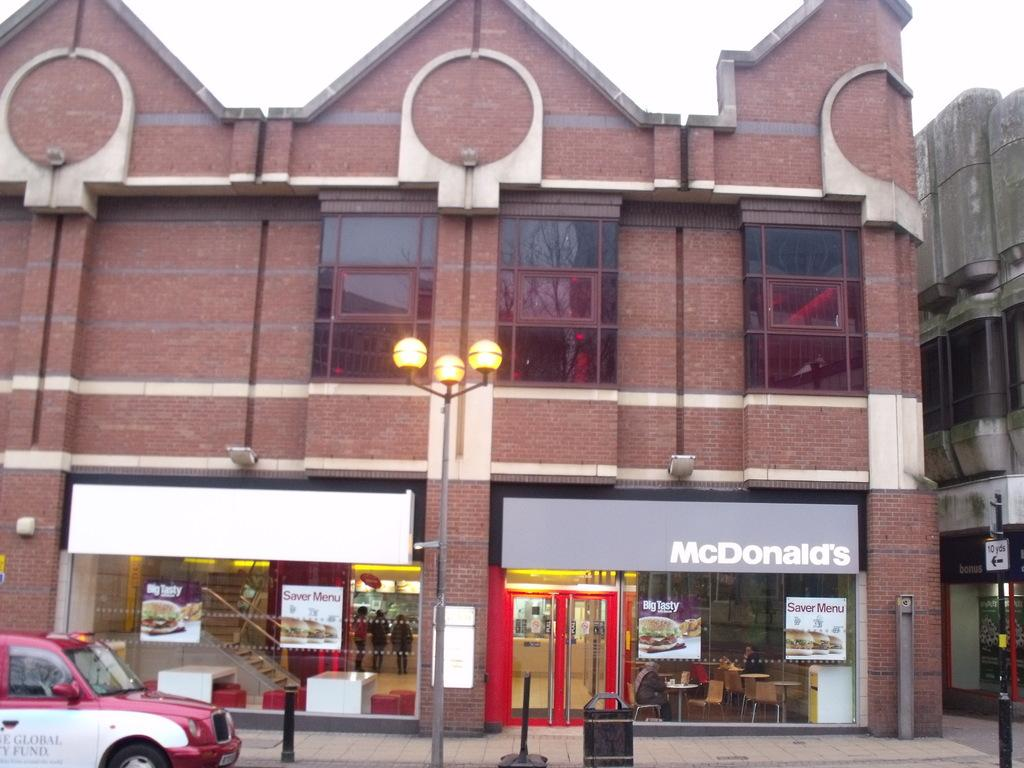<image>
Render a clear and concise summary of the photo. A McDonald's restaurant in a red brick building with lights in front. 